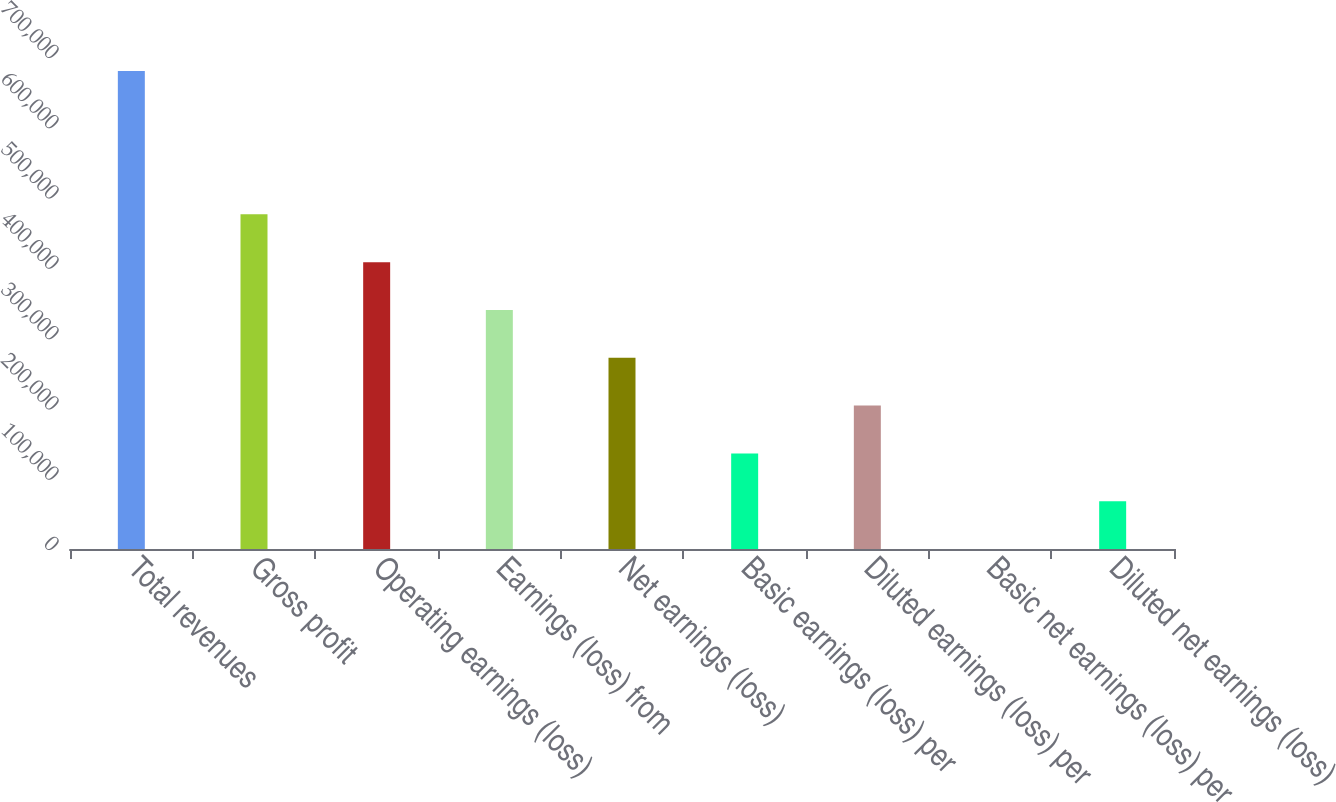Convert chart to OTSL. <chart><loc_0><loc_0><loc_500><loc_500><bar_chart><fcel>Total revenues<fcel>Gross profit<fcel>Operating earnings (loss)<fcel>Earnings (loss) from<fcel>Net earnings (loss)<fcel>Basic earnings (loss) per<fcel>Diluted earnings (loss) per<fcel>Basic net earnings (loss) per<fcel>Diluted net earnings (loss)<nl><fcel>680246<fcel>476172<fcel>408148<fcel>340123<fcel>272098<fcel>136049<fcel>204074<fcel>0.07<fcel>68024.7<nl></chart> 